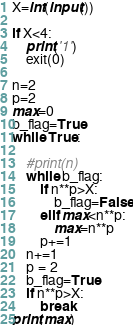Convert code to text. <code><loc_0><loc_0><loc_500><loc_500><_Python_>X=int(input())

if X<4:
    print('1')
    exit(0)

n=2
p=2
max=0
b_flag=True
while True:

    #print(n)
    while b_flag:
        if n**p>X:
            b_flag=False
        elif max<n**p:
            max=n**p
        p+=1
    n+=1
    p = 2
    b_flag=True
    if n**p>X:
        break
print(max)</code> 